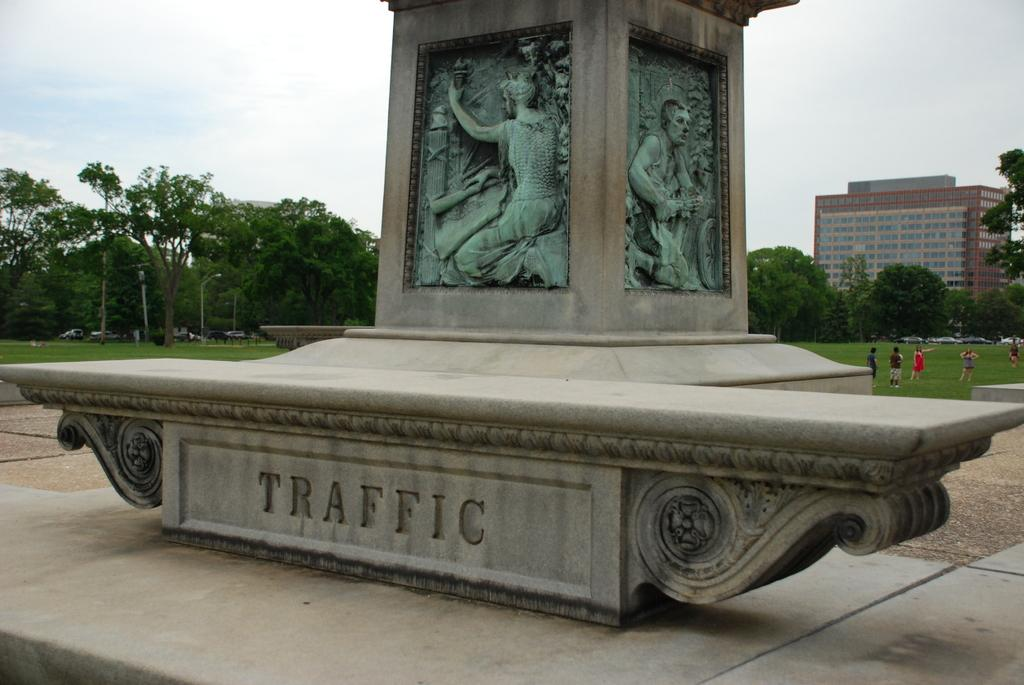How many statues are present in the image? There are two statues in the image. What else can be seen in the background of the image? There are people, trees, and a building visible in the background of the image. What is the condition of the sky in the image? There are clouds visible in the sky at the top of the image. What type of birds can be seen flying around the statues in the image? There are no birds visible in the image; it only features two statues, people, trees, a building, and clouds in the sky. 